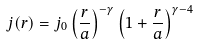Convert formula to latex. <formula><loc_0><loc_0><loc_500><loc_500>j ( r ) = j _ { 0 } \left ( \frac { r } { a } \right ) ^ { - \gamma } \left ( 1 + \frac { r } { a } \right ) ^ { \gamma - 4 }</formula> 